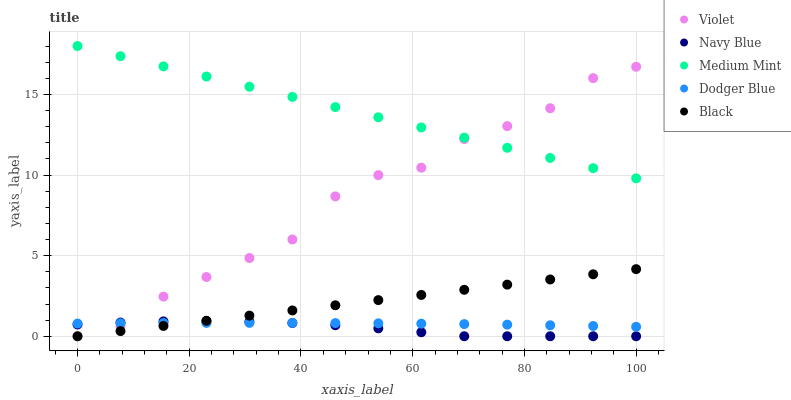Does Navy Blue have the minimum area under the curve?
Answer yes or no. Yes. Does Medium Mint have the maximum area under the curve?
Answer yes or no. Yes. Does Dodger Blue have the minimum area under the curve?
Answer yes or no. No. Does Dodger Blue have the maximum area under the curve?
Answer yes or no. No. Is Black the smoothest?
Answer yes or no. Yes. Is Violet the roughest?
Answer yes or no. Yes. Is Navy Blue the smoothest?
Answer yes or no. No. Is Navy Blue the roughest?
Answer yes or no. No. Does Navy Blue have the lowest value?
Answer yes or no. Yes. Does Dodger Blue have the lowest value?
Answer yes or no. No. Does Medium Mint have the highest value?
Answer yes or no. Yes. Does Navy Blue have the highest value?
Answer yes or no. No. Is Dodger Blue less than Medium Mint?
Answer yes or no. Yes. Is Medium Mint greater than Navy Blue?
Answer yes or no. Yes. Does Violet intersect Dodger Blue?
Answer yes or no. Yes. Is Violet less than Dodger Blue?
Answer yes or no. No. Is Violet greater than Dodger Blue?
Answer yes or no. No. Does Dodger Blue intersect Medium Mint?
Answer yes or no. No. 